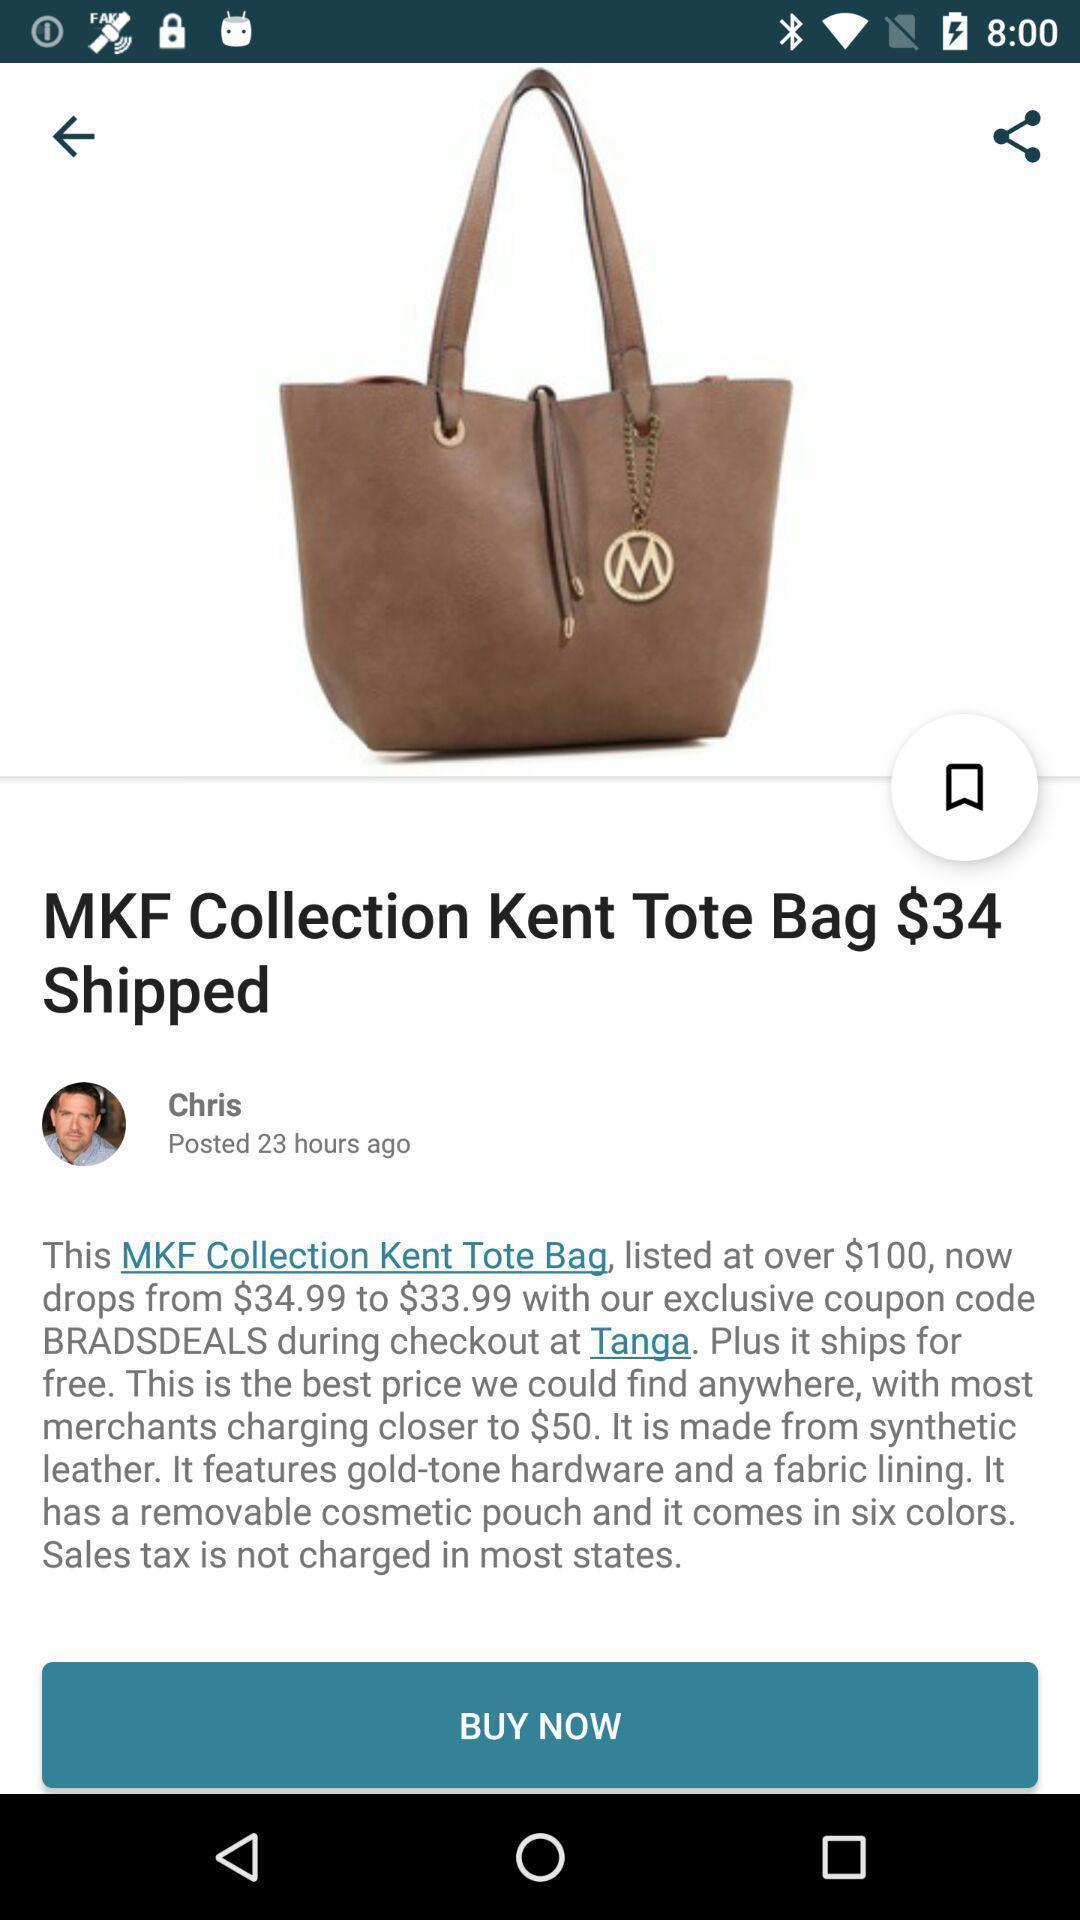Describe the content in this image. Page showing the product with its price. 